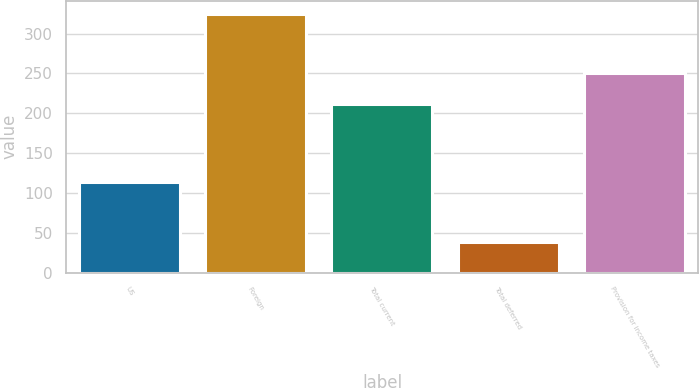Convert chart. <chart><loc_0><loc_0><loc_500><loc_500><bar_chart><fcel>US<fcel>Foreign<fcel>Total current<fcel>Total deferred<fcel>Provision for income taxes<nl><fcel>114<fcel>325<fcel>211<fcel>39<fcel>250<nl></chart> 